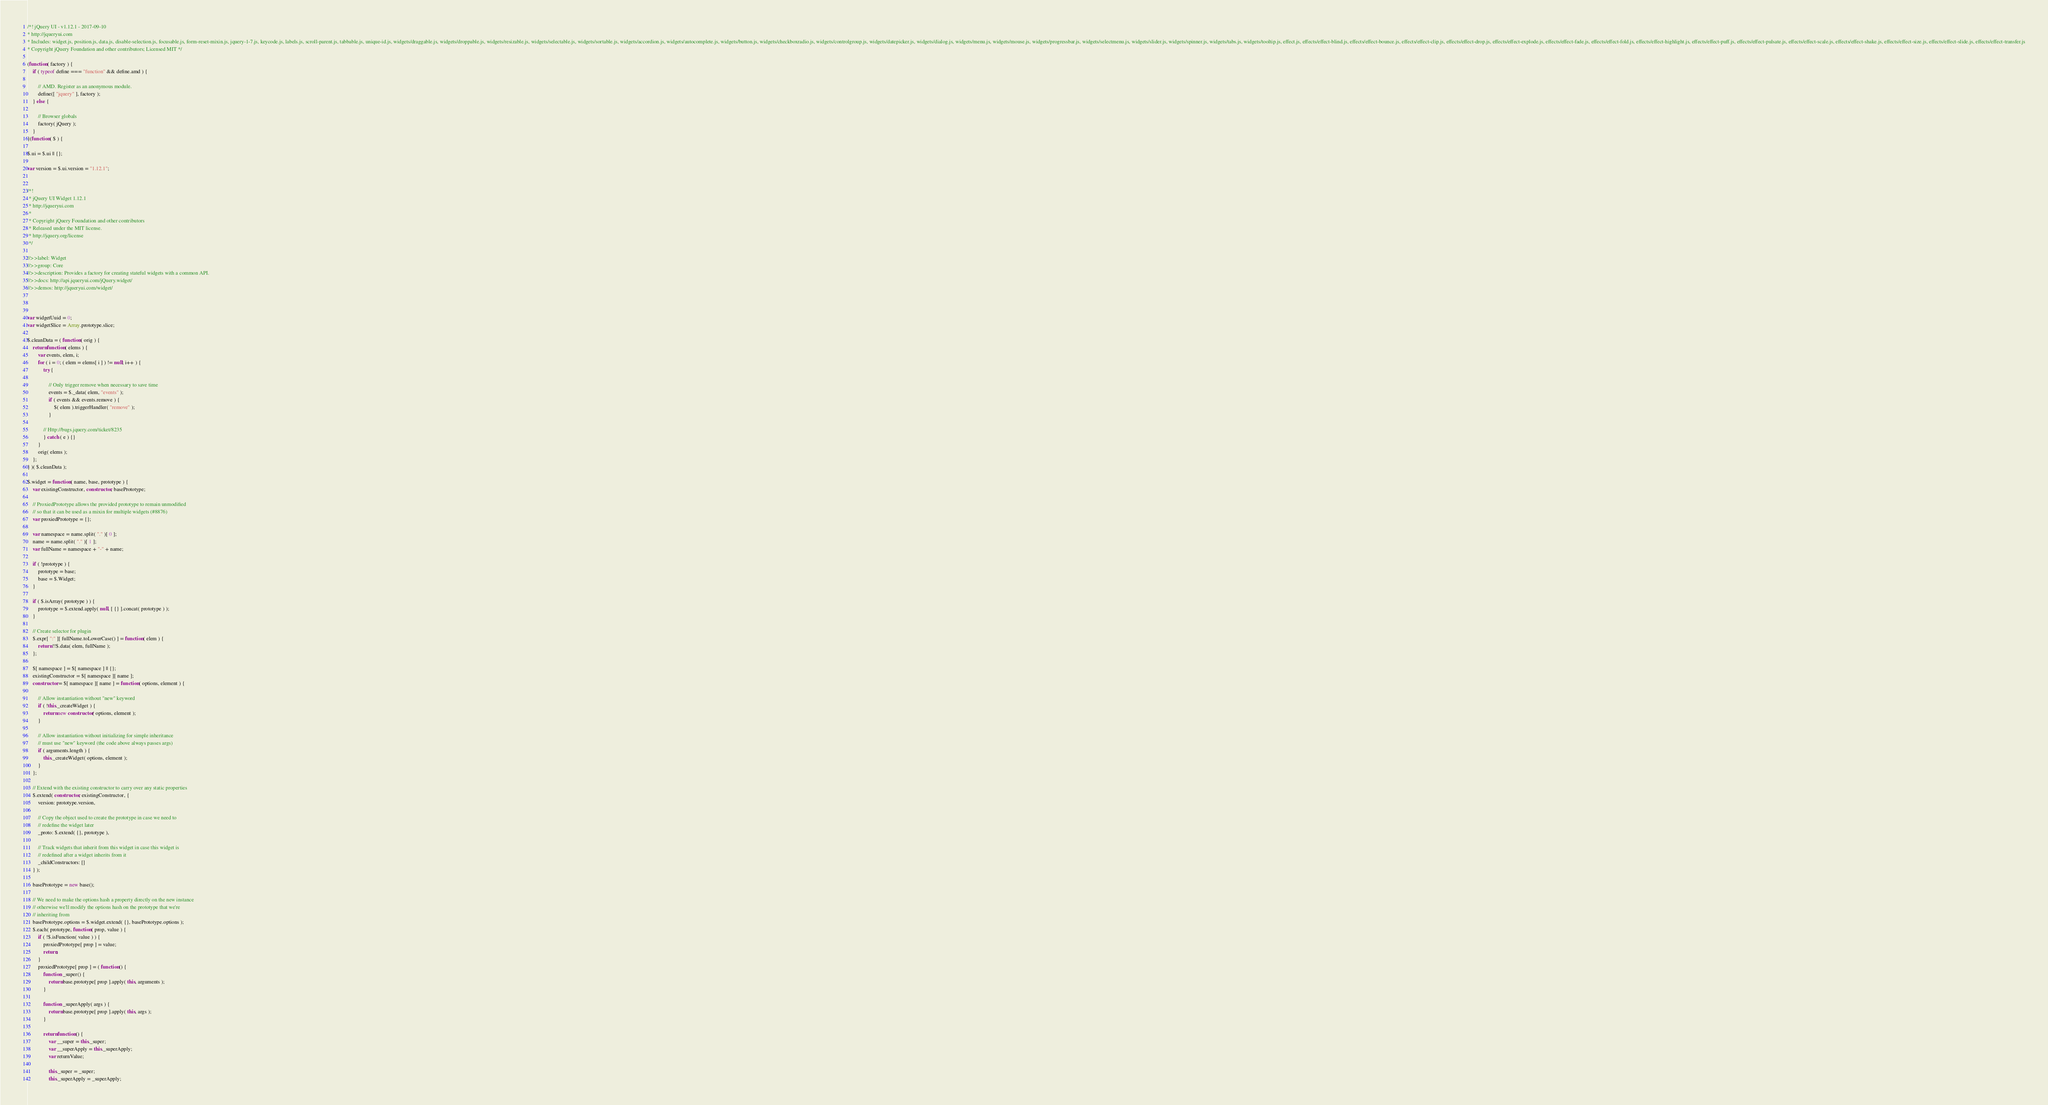<code> <loc_0><loc_0><loc_500><loc_500><_JavaScript_>/*! jQuery UI - v1.12.1 - 2017-09-10
* http://jqueryui.com
* Includes: widget.js, position.js, data.js, disable-selection.js, focusable.js, form-reset-mixin.js, jquery-1-7.js, keycode.js, labels.js, scroll-parent.js, tabbable.js, unique-id.js, widgets/draggable.js, widgets/droppable.js, widgets/resizable.js, widgets/selectable.js, widgets/sortable.js, widgets/accordion.js, widgets/autocomplete.js, widgets/button.js, widgets/checkboxradio.js, widgets/controlgroup.js, widgets/datepicker.js, widgets/dialog.js, widgets/menu.js, widgets/mouse.js, widgets/progressbar.js, widgets/selectmenu.js, widgets/slider.js, widgets/spinner.js, widgets/tabs.js, widgets/tooltip.js, effect.js, effects/effect-blind.js, effects/effect-bounce.js, effects/effect-clip.js, effects/effect-drop.js, effects/effect-explode.js, effects/effect-fade.js, effects/effect-fold.js, effects/effect-highlight.js, effects/effect-puff.js, effects/effect-pulsate.js, effects/effect-scale.js, effects/effect-shake.js, effects/effect-size.js, effects/effect-slide.js, effects/effect-transfer.js
* Copyright jQuery Foundation and other contributors; Licensed MIT */

(function( factory ) {
	if ( typeof define === "function" && define.amd ) {

		// AMD. Register as an anonymous module.
		define([ "jquery" ], factory );
	} else {

		// Browser globals
		factory( jQuery );
	}
}(function( $ ) {

$.ui = $.ui || {};

var version = $.ui.version = "1.12.1";


/*!
 * jQuery UI Widget 1.12.1
 * http://jqueryui.com
 *
 * Copyright jQuery Foundation and other contributors
 * Released under the MIT license.
 * http://jquery.org/license
 */

//>>label: Widget
//>>group: Core
//>>description: Provides a factory for creating stateful widgets with a common API.
//>>docs: http://api.jqueryui.com/jQuery.widget/
//>>demos: http://jqueryui.com/widget/



var widgetUuid = 0;
var widgetSlice = Array.prototype.slice;

$.cleanData = ( function( orig ) {
	return function( elems ) {
		var events, elem, i;
		for ( i = 0; ( elem = elems[ i ] ) != null; i++ ) {
			try {

				// Only trigger remove when necessary to save time
				events = $._data( elem, "events" );
				if ( events && events.remove ) {
					$( elem ).triggerHandler( "remove" );
				}

			// Http://bugs.jquery.com/ticket/8235
			} catch ( e ) {}
		}
		orig( elems );
	};
} )( $.cleanData );

$.widget = function( name, base, prototype ) {
	var existingConstructor, constructor, basePrototype;

	// ProxiedPrototype allows the provided prototype to remain unmodified
	// so that it can be used as a mixin for multiple widgets (#8876)
	var proxiedPrototype = {};

	var namespace = name.split( "." )[ 0 ];
	name = name.split( "." )[ 1 ];
	var fullName = namespace + "-" + name;

	if ( !prototype ) {
		prototype = base;
		base = $.Widget;
	}

	if ( $.isArray( prototype ) ) {
		prototype = $.extend.apply( null, [ {} ].concat( prototype ) );
	}

	// Create selector for plugin
	$.expr[ ":" ][ fullName.toLowerCase() ] = function( elem ) {
		return !!$.data( elem, fullName );
	};

	$[ namespace ] = $[ namespace ] || {};
	existingConstructor = $[ namespace ][ name ];
	constructor = $[ namespace ][ name ] = function( options, element ) {

		// Allow instantiation without "new" keyword
		if ( !this._createWidget ) {
			return new constructor( options, element );
		}

		// Allow instantiation without initializing for simple inheritance
		// must use "new" keyword (the code above always passes args)
		if ( arguments.length ) {
			this._createWidget( options, element );
		}
	};

	// Extend with the existing constructor to carry over any static properties
	$.extend( constructor, existingConstructor, {
		version: prototype.version,

		// Copy the object used to create the prototype in case we need to
		// redefine the widget later
		_proto: $.extend( {}, prototype ),

		// Track widgets that inherit from this widget in case this widget is
		// redefined after a widget inherits from it
		_childConstructors: []
	} );

	basePrototype = new base();

	// We need to make the options hash a property directly on the new instance
	// otherwise we'll modify the options hash on the prototype that we're
	// inheriting from
	basePrototype.options = $.widget.extend( {}, basePrototype.options );
	$.each( prototype, function( prop, value ) {
		if ( !$.isFunction( value ) ) {
			proxiedPrototype[ prop ] = value;
			return;
		}
		proxiedPrototype[ prop ] = ( function() {
			function _super() {
				return base.prototype[ prop ].apply( this, arguments );
			}

			function _superApply( args ) {
				return base.prototype[ prop ].apply( this, args );
			}

			return function() {
				var __super = this._super;
				var __superApply = this._superApply;
				var returnValue;

				this._super = _super;
				this._superApply = _superApply;
</code> 